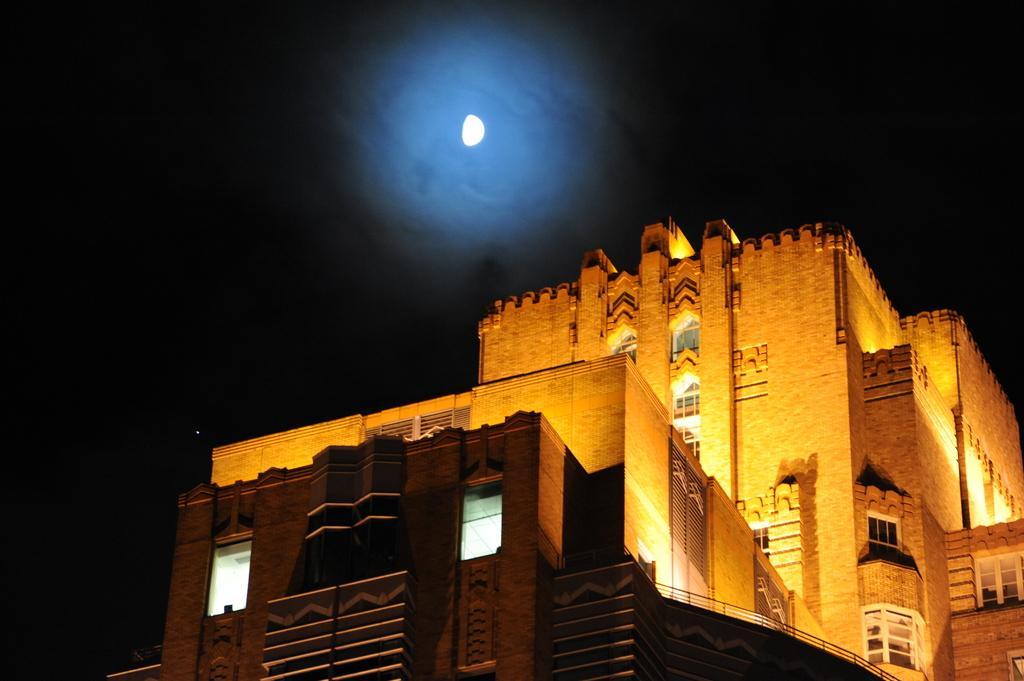Describe this image in one or two sentences. In this picture we can see a building with windows and in the background we can see the moon in the sky. 